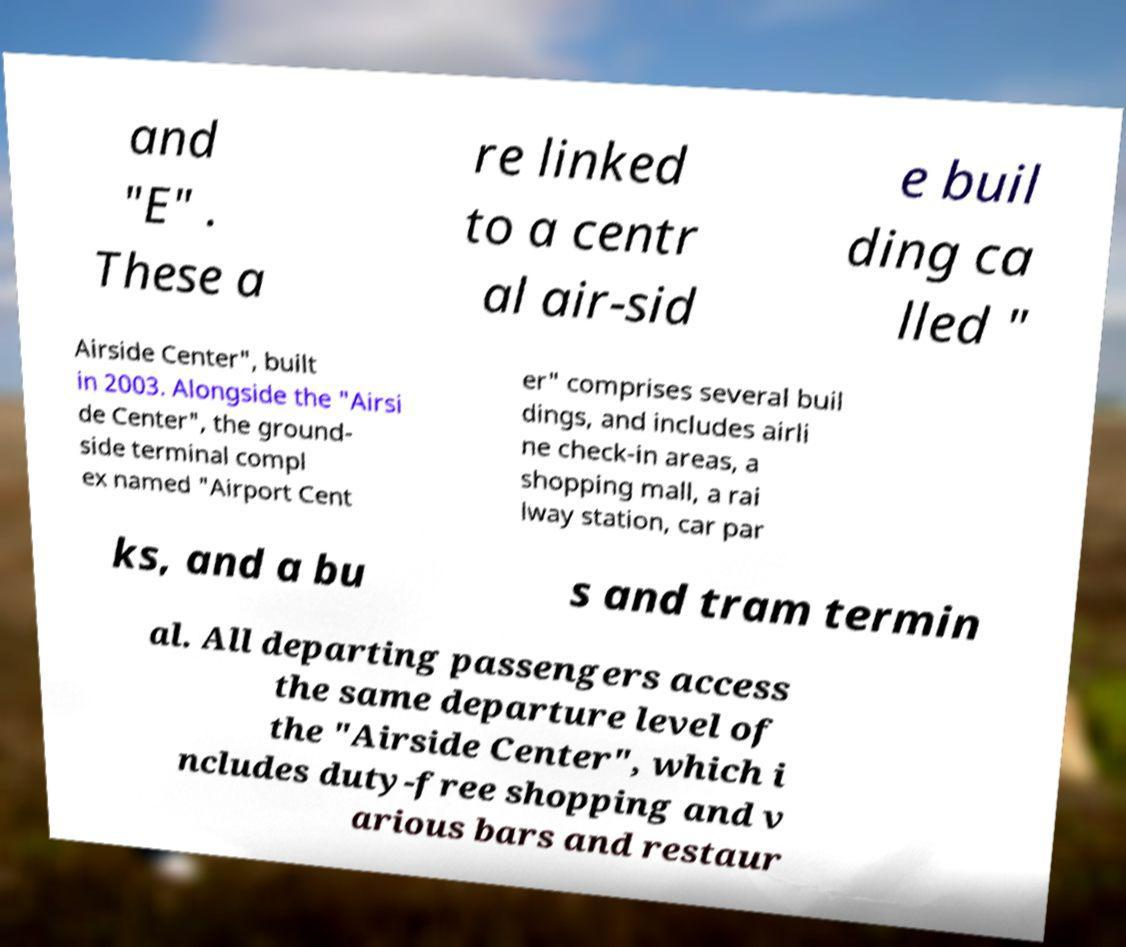Please identify and transcribe the text found in this image. and "E" . These a re linked to a centr al air-sid e buil ding ca lled " Airside Center", built in 2003. Alongside the "Airsi de Center", the ground- side terminal compl ex named "Airport Cent er" comprises several buil dings, and includes airli ne check-in areas, a shopping mall, a rai lway station, car par ks, and a bu s and tram termin al. All departing passengers access the same departure level of the "Airside Center", which i ncludes duty-free shopping and v arious bars and restaur 